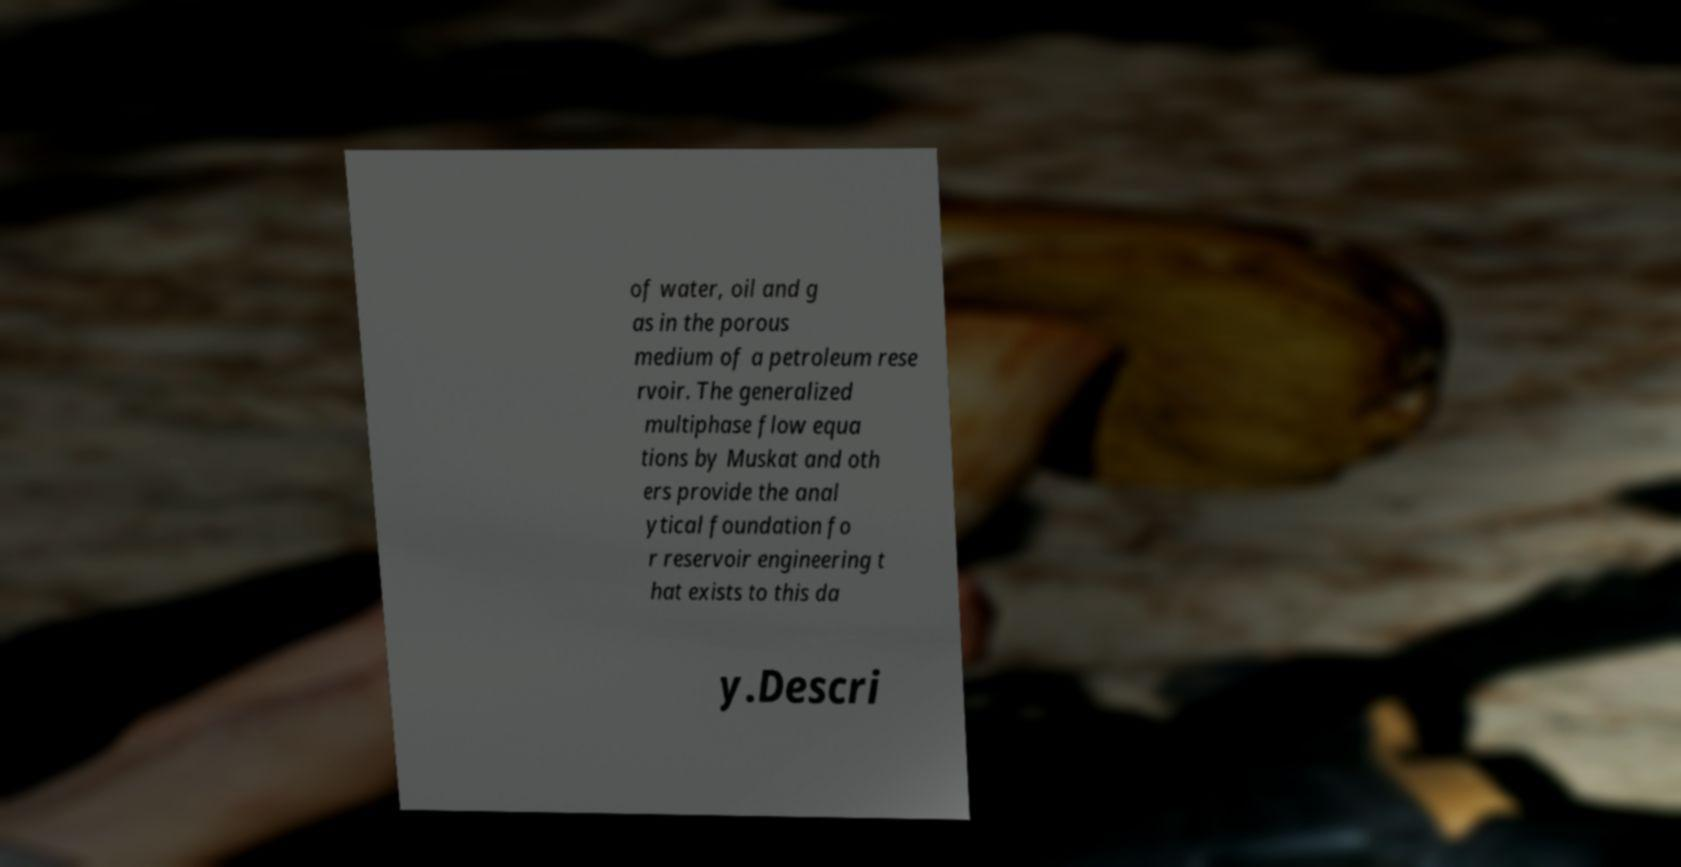Please identify and transcribe the text found in this image. of water, oil and g as in the porous medium of a petroleum rese rvoir. The generalized multiphase flow equa tions by Muskat and oth ers provide the anal ytical foundation fo r reservoir engineering t hat exists to this da y.Descri 